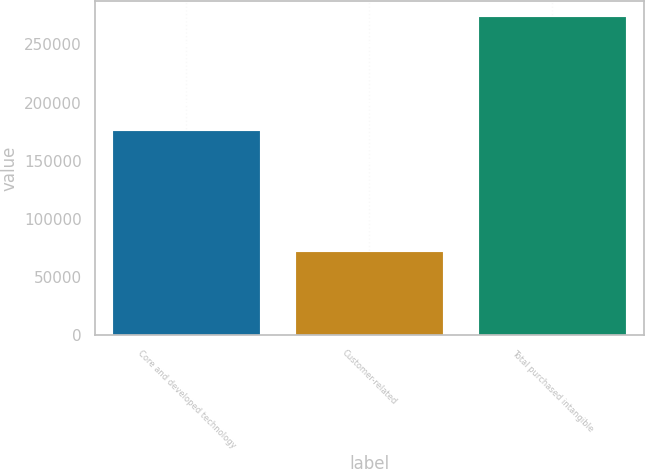<chart> <loc_0><loc_0><loc_500><loc_500><bar_chart><fcel>Core and developed technology<fcel>Customer-related<fcel>Total purchased intangible<nl><fcel>175800<fcel>71100<fcel>273500<nl></chart> 